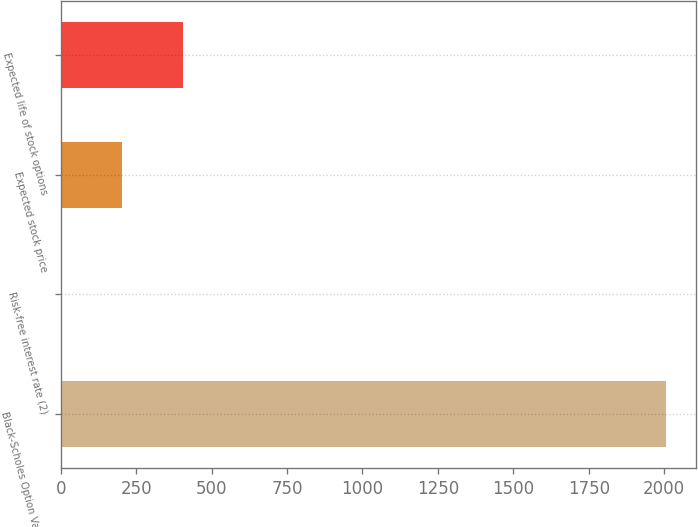<chart> <loc_0><loc_0><loc_500><loc_500><bar_chart><fcel>Black-Scholes Option Valuation<fcel>Risk-free interest rate (2)<fcel>Expected stock price<fcel>Expected life of stock options<nl><fcel>2006<fcel>4.6<fcel>204.74<fcel>404.88<nl></chart> 